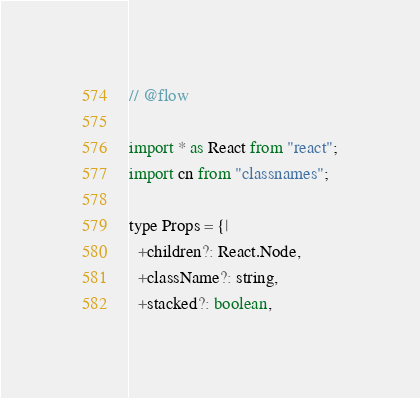<code> <loc_0><loc_0><loc_500><loc_500><_JavaScript_>// @flow

import * as React from "react";
import cn from "classnames";

type Props = {|
  +children?: React.Node,
  +className?: string,
  +stacked?: boolean,</code> 